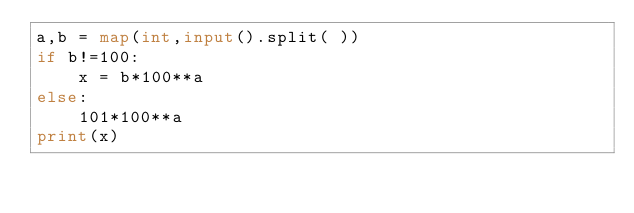<code> <loc_0><loc_0><loc_500><loc_500><_Python_>a,b = map(int,input().split( ))
if b!=100:
    x = b*100**a
else:
    101*100**a
print(x)</code> 